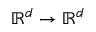Convert formula to latex. <formula><loc_0><loc_0><loc_500><loc_500>\mathbb { R } ^ { d } \rightarrow \mathbb { R } ^ { d }</formula> 